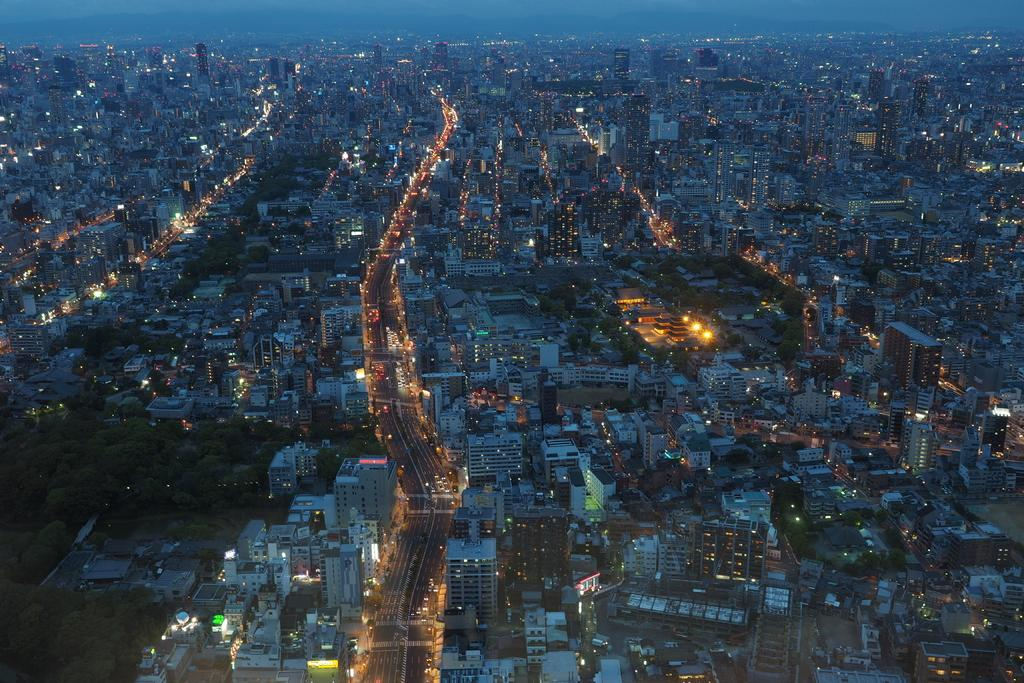What can be seen in the foreground of the image? There are many buildings in the foreground of the image. What else is visible in the image besides the buildings? Lights, roads, trees, and the sky are visible in the image. Can you describe the roads in the image? Roads are present in the image. What is visible at the top of the image? The sky is visible at the top of the image. Where is the desk located in the image? There is no desk present in the image. What type of boundary can be seen separating the buildings in the image? There is no boundary separating the buildings in the image; only roads and trees are visible between them. 